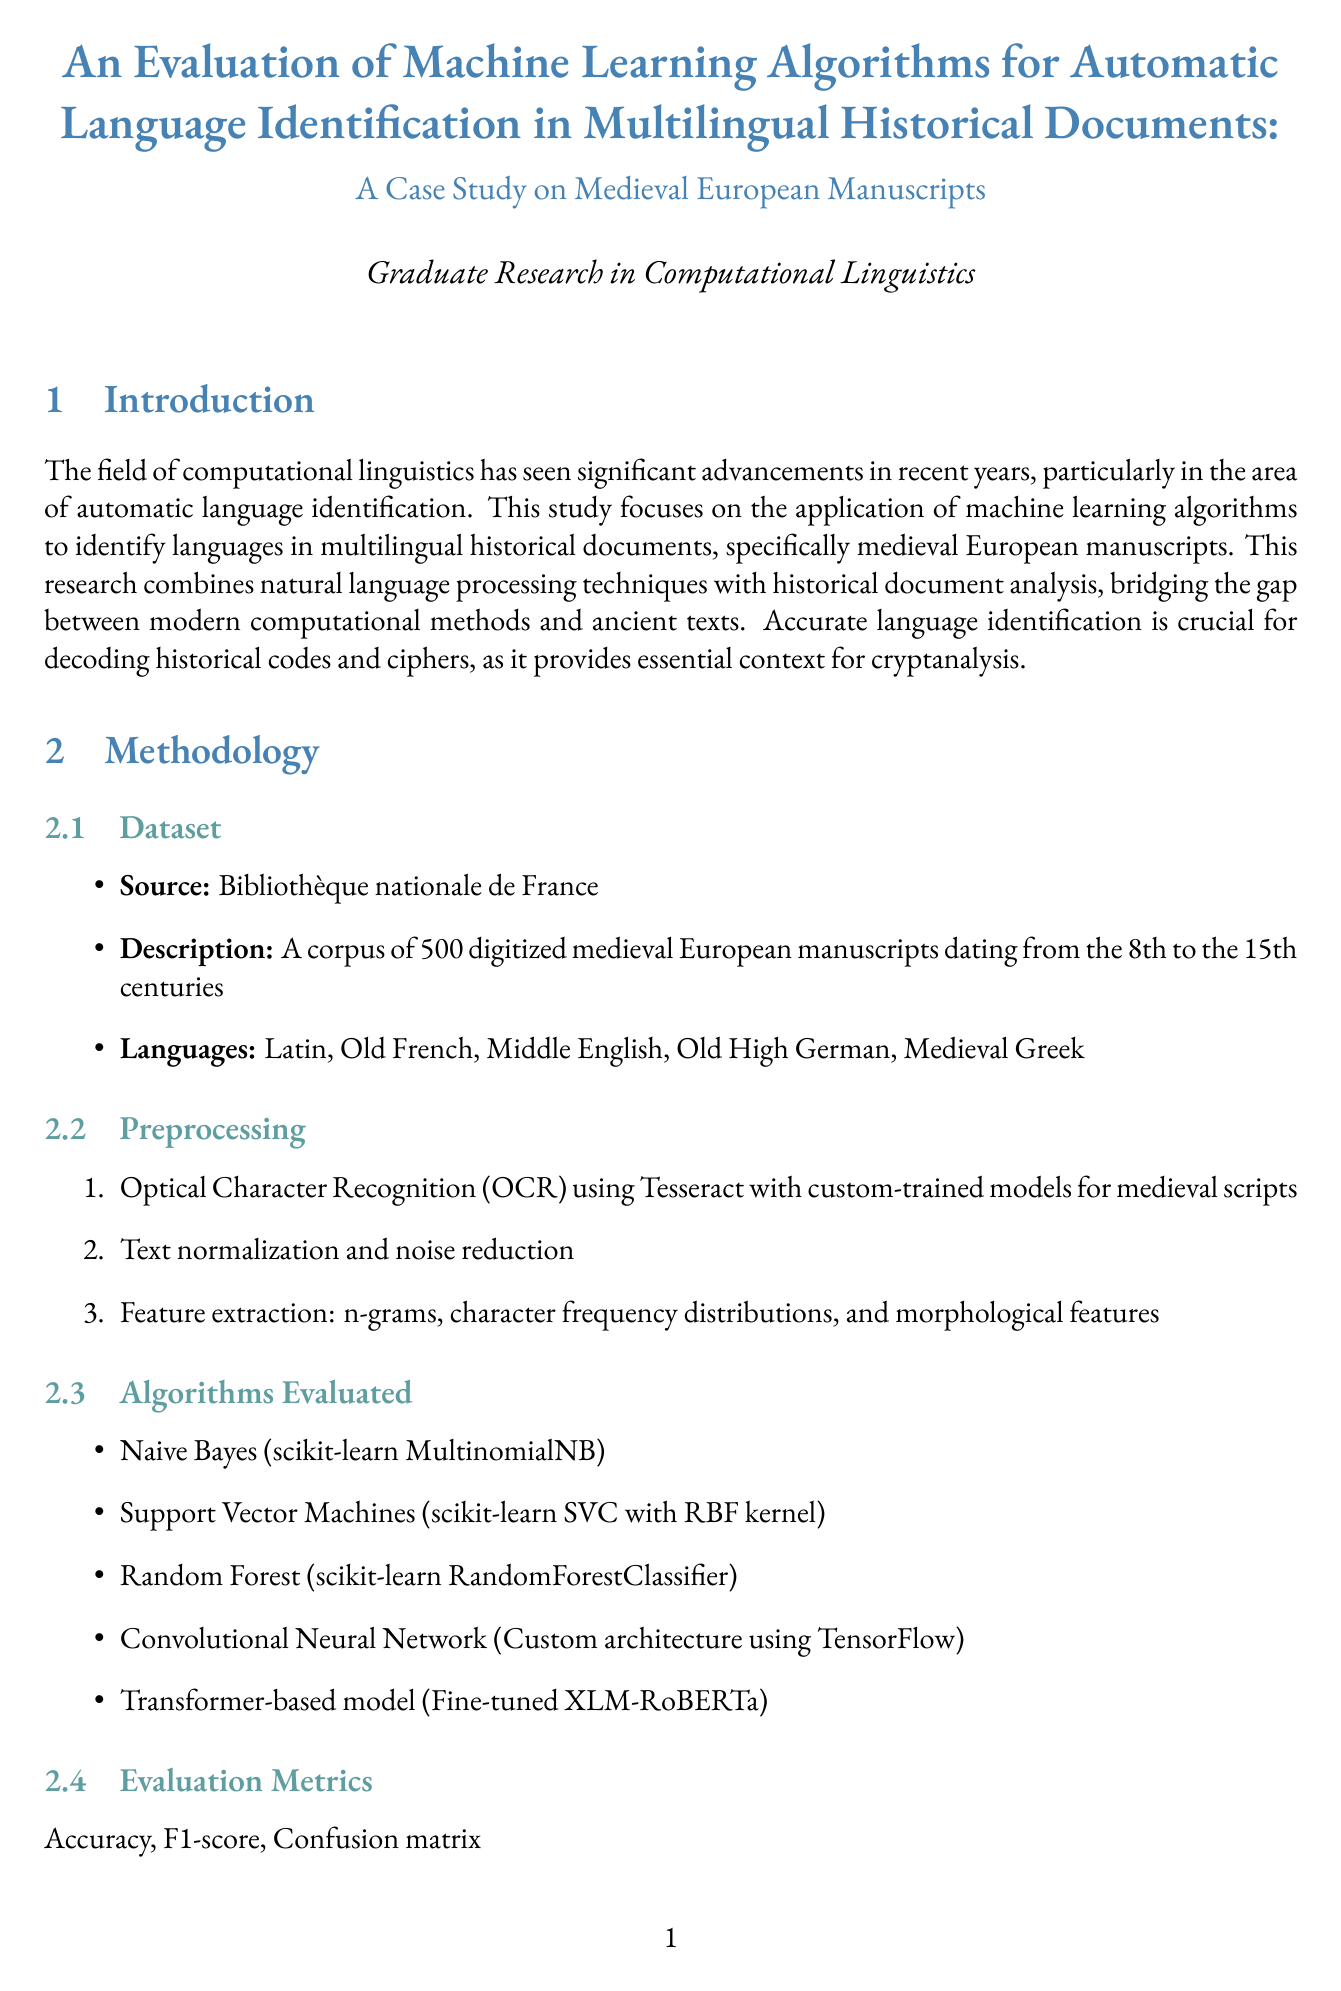What is the title of the report? The title is stated at the beginning of the document, highlighting the focus and case study of the research.
Answer: An Evaluation of Machine Learning Algorithms for Automatic Language Identification in Multilingual Historical Documents: A Case Study on Medieval European Manuscripts What is the best algorithm reported? The overall performance section specifies the best algorithm evaluated in the study.
Answer: Transformer-based model (XLM-RoBERTa) How many manuscripts were included in the dataset? The dataset description mentions the total number of digitized medieval manuscripts analyzed in the study.
Answer: 500 What language had the highest precision? The language-specific results provide precision data for each language, and Latin is noted for having the highest precision.
Answer: Latin What is one of the challenges encountered during the study? The challenges section lists various difficulties faced in applying machine learning to historical documents, focusing on specific issues.
Answer: Dealing with mixed-language texts and code-switching What evaluation metrics were used in the study? The methodology section lists the metrics applied to assess the machine learning algorithms' performance.
Answer: Accuracy, F1-score, Confusion matrix What are the future research directions mentioned? The future research section outlines potential areas for further exploration suggested by the findings of the study.
Answer: Incorporating paleographic features to improve accuracy What was the accuracy achieved by the best algorithm? The overall performance section provides the accuracy value for the best-performing algorithm in the study.
Answer: 0.94 